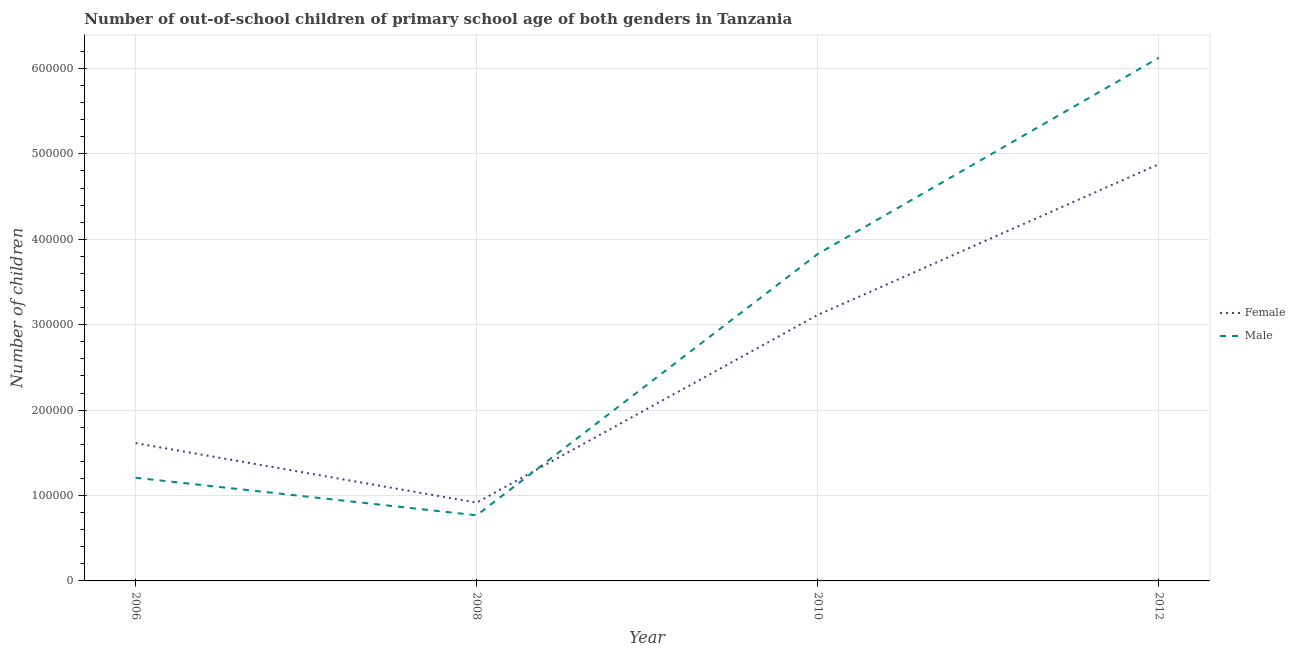How many different coloured lines are there?
Make the answer very short. 2. What is the number of female out-of-school students in 2008?
Ensure brevity in your answer.  9.16e+04. Across all years, what is the maximum number of male out-of-school students?
Your answer should be very brief. 6.13e+05. Across all years, what is the minimum number of male out-of-school students?
Offer a very short reply. 7.68e+04. In which year was the number of male out-of-school students minimum?
Ensure brevity in your answer.  2008. What is the total number of female out-of-school students in the graph?
Keep it short and to the point. 1.05e+06. What is the difference between the number of female out-of-school students in 2010 and that in 2012?
Provide a short and direct response. -1.76e+05. What is the difference between the number of female out-of-school students in 2008 and the number of male out-of-school students in 2010?
Offer a very short reply. -2.91e+05. What is the average number of male out-of-school students per year?
Your answer should be compact. 2.98e+05. In the year 2010, what is the difference between the number of male out-of-school students and number of female out-of-school students?
Ensure brevity in your answer.  7.14e+04. In how many years, is the number of female out-of-school students greater than 420000?
Your answer should be compact. 1. What is the ratio of the number of female out-of-school students in 2010 to that in 2012?
Ensure brevity in your answer.  0.64. What is the difference between the highest and the second highest number of male out-of-school students?
Make the answer very short. 2.30e+05. What is the difference between the highest and the lowest number of female out-of-school students?
Your answer should be very brief. 3.96e+05. Does the number of female out-of-school students monotonically increase over the years?
Your answer should be compact. No. Is the number of male out-of-school students strictly greater than the number of female out-of-school students over the years?
Offer a terse response. No. Is the number of male out-of-school students strictly less than the number of female out-of-school students over the years?
Make the answer very short. No. Where does the legend appear in the graph?
Keep it short and to the point. Center right. What is the title of the graph?
Your answer should be very brief. Number of out-of-school children of primary school age of both genders in Tanzania. What is the label or title of the X-axis?
Make the answer very short. Year. What is the label or title of the Y-axis?
Offer a very short reply. Number of children. What is the Number of children in Female in 2006?
Ensure brevity in your answer.  1.61e+05. What is the Number of children of Male in 2006?
Your answer should be compact. 1.21e+05. What is the Number of children in Female in 2008?
Your answer should be compact. 9.16e+04. What is the Number of children in Male in 2008?
Provide a succinct answer. 7.68e+04. What is the Number of children in Female in 2010?
Ensure brevity in your answer.  3.11e+05. What is the Number of children in Male in 2010?
Offer a very short reply. 3.83e+05. What is the Number of children in Female in 2012?
Your answer should be compact. 4.88e+05. What is the Number of children of Male in 2012?
Make the answer very short. 6.13e+05. Across all years, what is the maximum Number of children of Female?
Provide a short and direct response. 4.88e+05. Across all years, what is the maximum Number of children of Male?
Offer a terse response. 6.13e+05. Across all years, what is the minimum Number of children in Female?
Make the answer very short. 9.16e+04. Across all years, what is the minimum Number of children in Male?
Offer a terse response. 7.68e+04. What is the total Number of children in Female in the graph?
Your answer should be compact. 1.05e+06. What is the total Number of children of Male in the graph?
Your response must be concise. 1.19e+06. What is the difference between the Number of children in Female in 2006 and that in 2008?
Offer a very short reply. 6.97e+04. What is the difference between the Number of children in Male in 2006 and that in 2008?
Ensure brevity in your answer.  4.40e+04. What is the difference between the Number of children in Female in 2006 and that in 2010?
Keep it short and to the point. -1.50e+05. What is the difference between the Number of children in Male in 2006 and that in 2010?
Make the answer very short. -2.62e+05. What is the difference between the Number of children in Female in 2006 and that in 2012?
Offer a very short reply. -3.27e+05. What is the difference between the Number of children of Male in 2006 and that in 2012?
Make the answer very short. -4.92e+05. What is the difference between the Number of children of Female in 2008 and that in 2010?
Your response must be concise. -2.20e+05. What is the difference between the Number of children of Male in 2008 and that in 2010?
Offer a very short reply. -3.06e+05. What is the difference between the Number of children of Female in 2008 and that in 2012?
Your answer should be very brief. -3.96e+05. What is the difference between the Number of children of Male in 2008 and that in 2012?
Give a very brief answer. -5.36e+05. What is the difference between the Number of children in Female in 2010 and that in 2012?
Provide a short and direct response. -1.76e+05. What is the difference between the Number of children in Male in 2010 and that in 2012?
Make the answer very short. -2.30e+05. What is the difference between the Number of children of Female in 2006 and the Number of children of Male in 2008?
Provide a short and direct response. 8.45e+04. What is the difference between the Number of children of Female in 2006 and the Number of children of Male in 2010?
Offer a terse response. -2.21e+05. What is the difference between the Number of children of Female in 2006 and the Number of children of Male in 2012?
Give a very brief answer. -4.51e+05. What is the difference between the Number of children in Female in 2008 and the Number of children in Male in 2010?
Your answer should be compact. -2.91e+05. What is the difference between the Number of children in Female in 2008 and the Number of children in Male in 2012?
Keep it short and to the point. -5.21e+05. What is the difference between the Number of children in Female in 2010 and the Number of children in Male in 2012?
Provide a succinct answer. -3.01e+05. What is the average Number of children of Female per year?
Give a very brief answer. 2.63e+05. What is the average Number of children in Male per year?
Make the answer very short. 2.98e+05. In the year 2006, what is the difference between the Number of children in Female and Number of children in Male?
Provide a short and direct response. 4.05e+04. In the year 2008, what is the difference between the Number of children in Female and Number of children in Male?
Offer a very short reply. 1.48e+04. In the year 2010, what is the difference between the Number of children in Female and Number of children in Male?
Offer a very short reply. -7.14e+04. In the year 2012, what is the difference between the Number of children in Female and Number of children in Male?
Provide a short and direct response. -1.25e+05. What is the ratio of the Number of children in Female in 2006 to that in 2008?
Ensure brevity in your answer.  1.76. What is the ratio of the Number of children in Male in 2006 to that in 2008?
Your response must be concise. 1.57. What is the ratio of the Number of children in Female in 2006 to that in 2010?
Make the answer very short. 0.52. What is the ratio of the Number of children of Male in 2006 to that in 2010?
Provide a short and direct response. 0.32. What is the ratio of the Number of children in Female in 2006 to that in 2012?
Provide a short and direct response. 0.33. What is the ratio of the Number of children in Male in 2006 to that in 2012?
Your response must be concise. 0.2. What is the ratio of the Number of children of Female in 2008 to that in 2010?
Your answer should be very brief. 0.29. What is the ratio of the Number of children in Male in 2008 to that in 2010?
Your answer should be compact. 0.2. What is the ratio of the Number of children in Female in 2008 to that in 2012?
Make the answer very short. 0.19. What is the ratio of the Number of children in Male in 2008 to that in 2012?
Your response must be concise. 0.13. What is the ratio of the Number of children in Female in 2010 to that in 2012?
Your response must be concise. 0.64. What is the ratio of the Number of children in Male in 2010 to that in 2012?
Your response must be concise. 0.62. What is the difference between the highest and the second highest Number of children of Female?
Keep it short and to the point. 1.76e+05. What is the difference between the highest and the second highest Number of children in Male?
Offer a terse response. 2.30e+05. What is the difference between the highest and the lowest Number of children in Female?
Your answer should be very brief. 3.96e+05. What is the difference between the highest and the lowest Number of children of Male?
Your answer should be compact. 5.36e+05. 